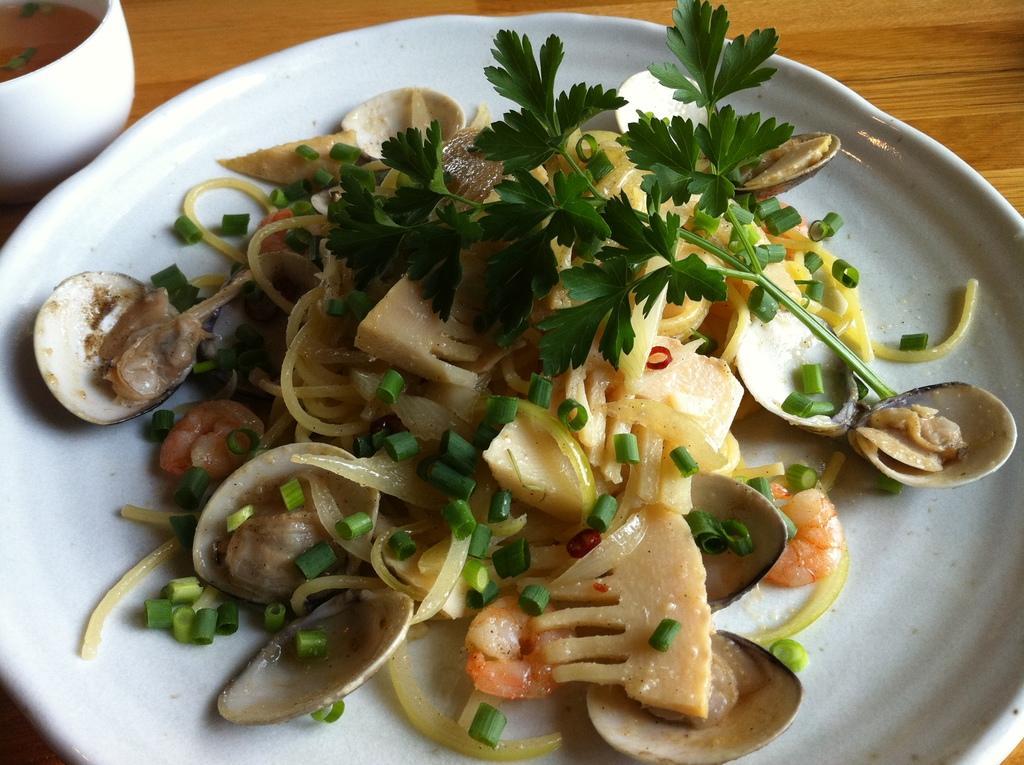Describe this image in one or two sentences. In this image, we can see a white plate is placed on the wooden surface. Some eatable things, food item is placed on the plate. On the left side, there is a white bowl with some liquid. 